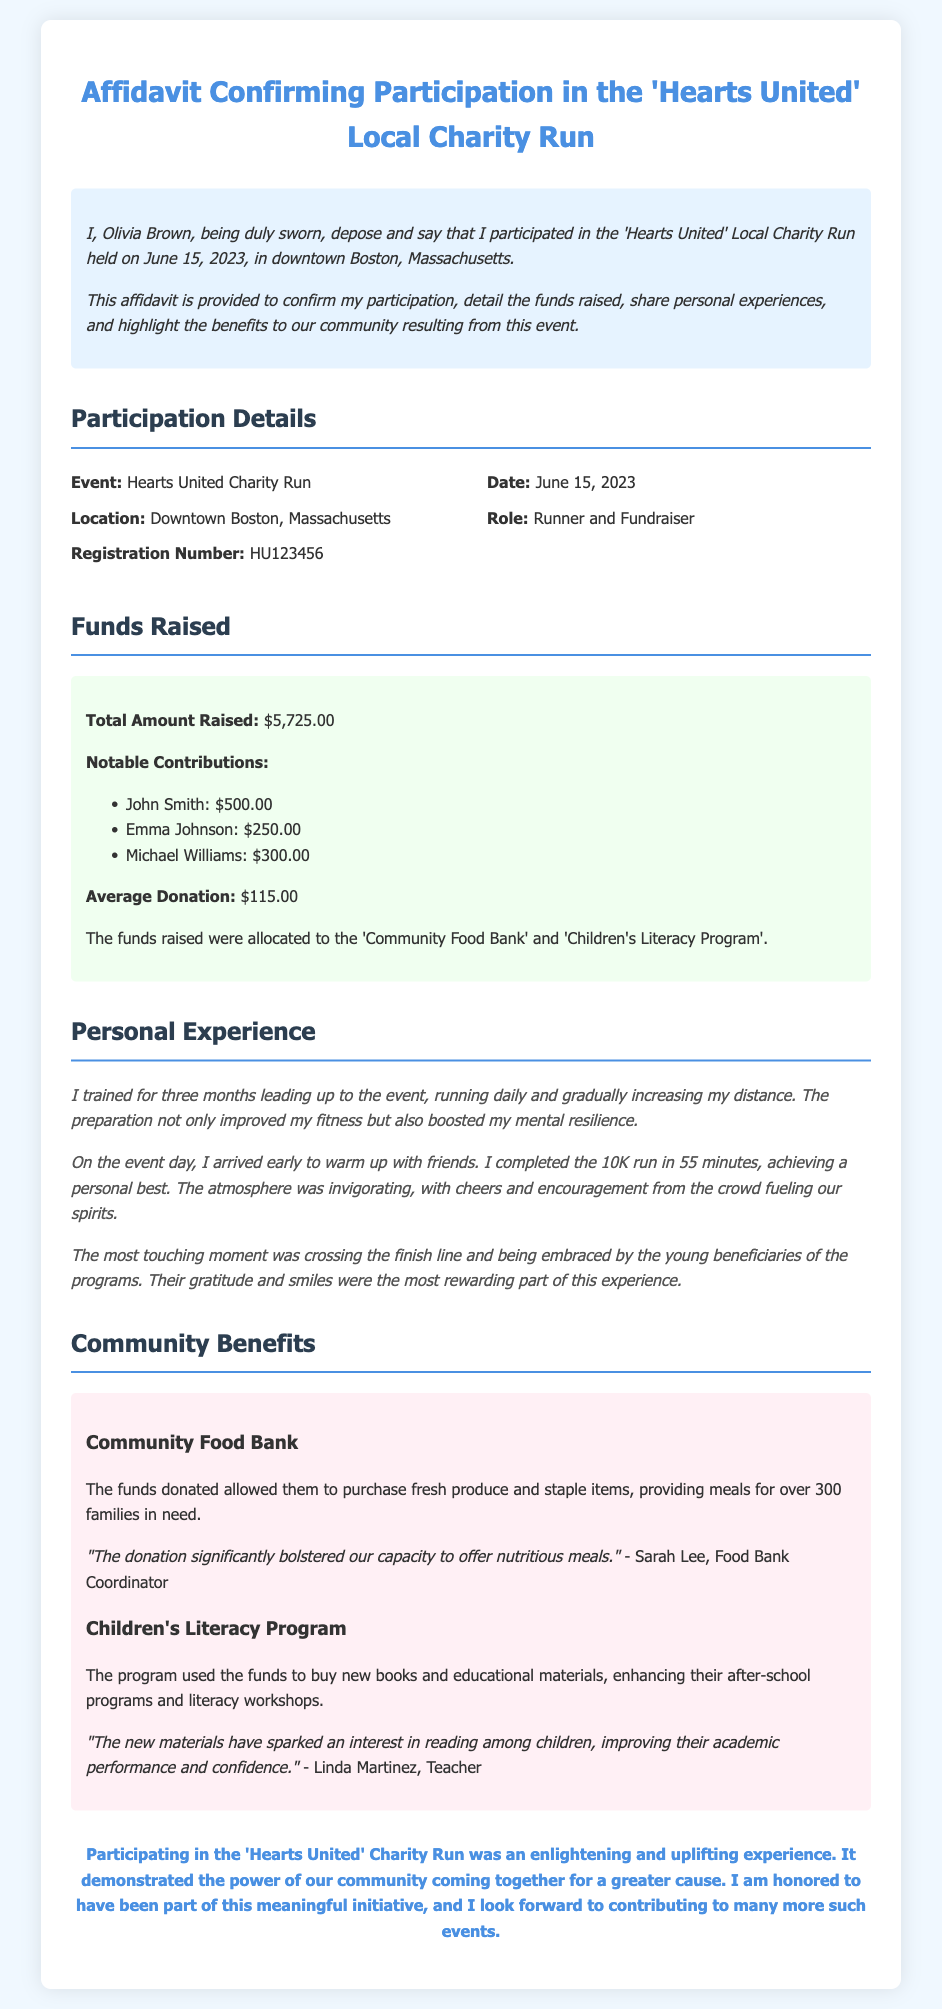What is the total amount raised? The total amount raised is specified in the Funds Raised section of the document.
Answer: $5,725.00 Who is the participant mentioned in the affidavit? The participant's name is provided at the beginning of the document, in the introductory paragraph.
Answer: Olivia Brown What is the date of the charity run? The date can be found in the Participation Details section of the document.
Answer: June 15, 2023 How long did Olivia train for the event? The training duration is mentioned in the Personal Experience section of the document.
Answer: Three months What was Olivia's completion time for the 10K run? The completion time is included in the Personal Experience section of the document.
Answer: 55 minutes Which organization received the funds for food assistance? The organization benefiting from the funds for food assistance is mentioned in the Community Benefits section of the document.
Answer: Community Food Bank What is the role of Olivia in the charity run? The role is indicated in the Participation Details section of the document.
Answer: Runner and Fundraiser What was John Smith's contribution amount? The specific contribution amount from John Smith is listed under Notable Contributions in the Funds Raised section.
Answer: $500.00 